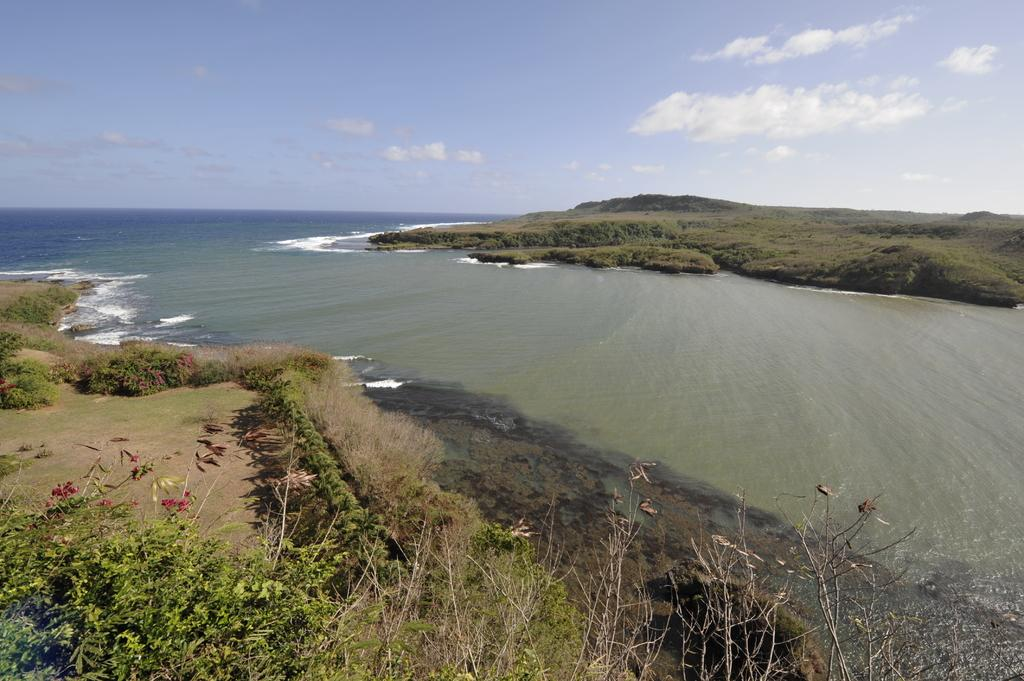What can be seen in the image? There is water visible in the image. What is located to the left of the water? There is grass to the left of the water. What type of flowers can be seen near the grass? There are red color flowers on the plants near the grass. What is visible in the background of the image? There is grass and clouds visible in the background. What part of the sky is visible in the image? The sky is visible in the background. Where is the cannon located in the image? There is no cannon present in the image. What type of plough is being used to cultivate the grass in the image? There is no plough present in the image; it features grass and water. Is there any fire visible in the image? No, there is no fire visible in the image. 